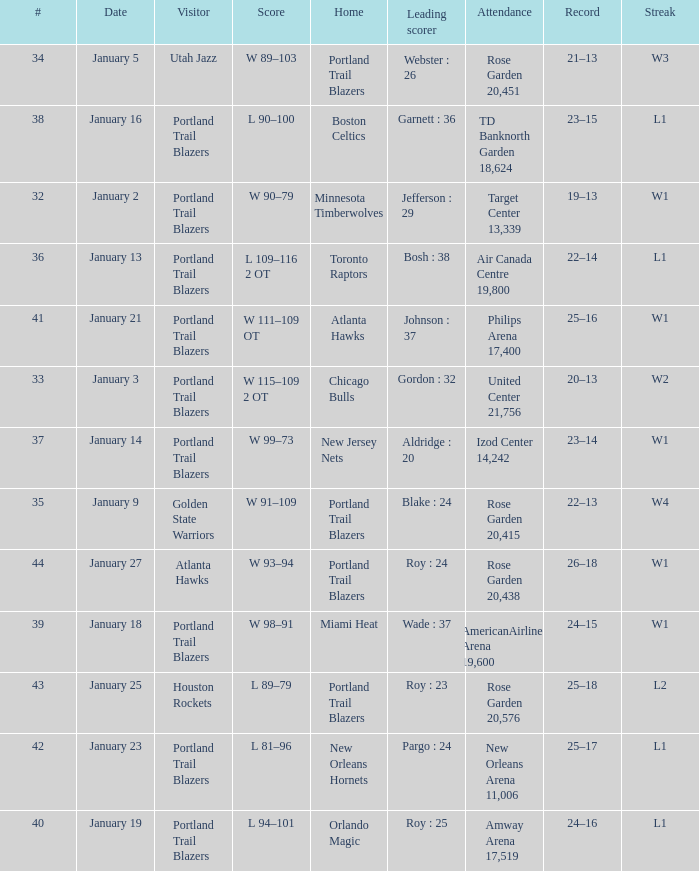Which visitors have a leading scorer of roy : 25 Portland Trail Blazers. 